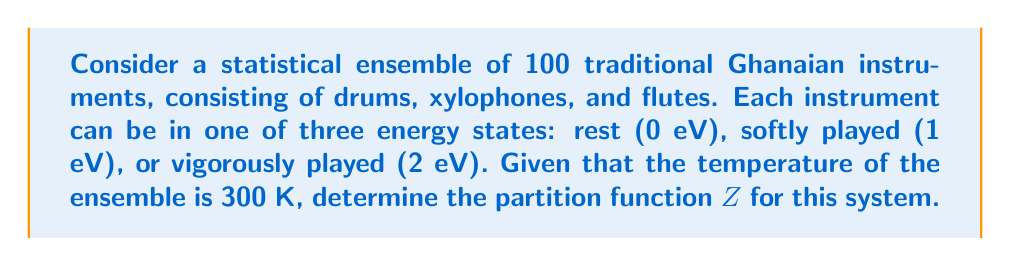What is the answer to this math problem? Let's approach this step-by-step:

1) The partition function Z for a system with discrete energy levels is given by:

   $$Z = \sum_i g_i e^{-\beta E_i}$$

   where $g_i$ is the degeneracy of energy level $E_i$, and $\beta = \frac{1}{k_B T}$.

2) In this case, we have three energy levels:
   $E_1 = 0$ eV (rest)
   $E_2 = 1$ eV (softly played)
   $E_3 = 2$ eV (vigorously played)

3) The degeneracy $g_i$ for each level is 100, as each of the 100 instruments can be in any of these states.

4) We need to calculate $\beta$:
   $$\beta = \frac{1}{k_B T} = \frac{1}{(8.617 \times 10^{-5} \text{ eV/K})(300 \text{ K})} = 38.68 \text{ eV}^{-1}$$

5) Now, let's calculate each term of the partition function:
   
   For $E_1$: $100 e^{-38.68 \times 0} = 100$
   
   For $E_2$: $100 e^{-38.68 \times 1} = 100 e^{-38.68} = 1.42 \times 10^{-15}$
   
   For $E_3$: $100 e^{-38.68 \times 2} = 100 e^{-77.36} = 2.02 \times 10^{-32}$

6) The partition function is the sum of these terms:

   $$Z = 100 + 1.42 \times 10^{-15} + 2.02 \times 10^{-32}$$

7) The last two terms are negligibly small compared to 100, so we can approximate:

   $$Z \approx 100$$
Answer: $Z \approx 100$ 